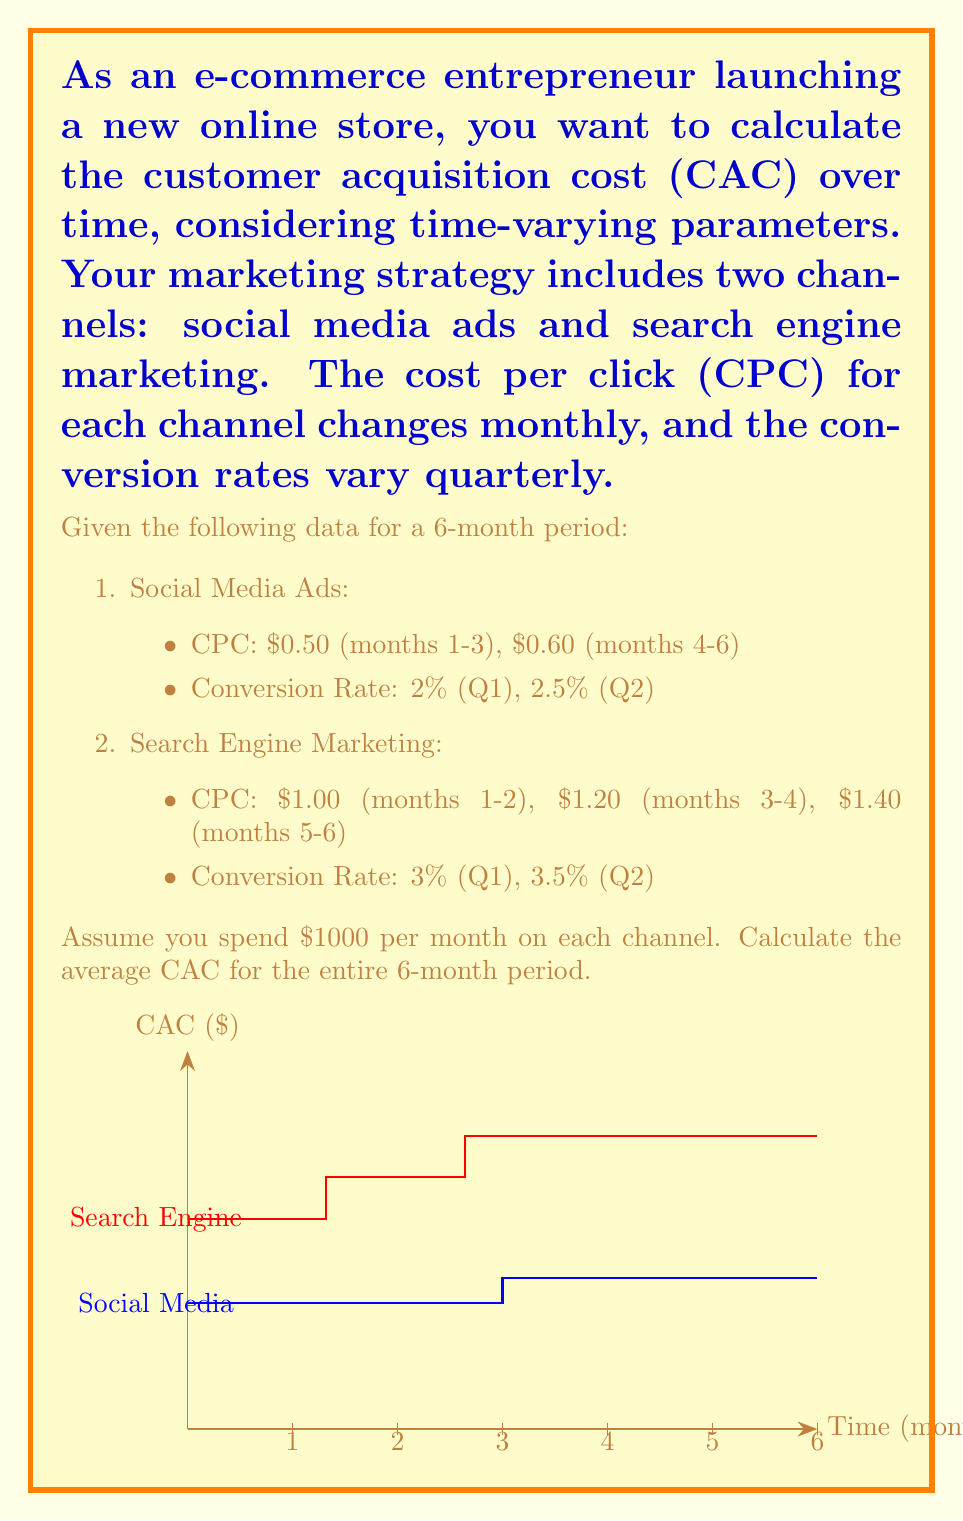Provide a solution to this math problem. To calculate the average Customer Acquisition Cost (CAC) over the 6-month period, we need to:

1. Calculate the number of customers acquired through each channel for each month.
2. Calculate the total cost for each channel.
3. Sum up the total customers and total costs.
4. Divide the total cost by the total number of customers.

Let's break it down step by step:

1. Number of customers acquired:

   Social Media Ads:
   - Months 1-3: $\frac{1000}{0.50} \times 0.02 = 40$ customers/month
   - Months 4-6: $\frac{1000}{0.60} \times 0.025 = 41.67$ customers/month
   
   Search Engine Marketing:
   - Months 1-2: $\frac{1000}{1.00} \times 0.03 = 30$ customers/month
   - Months 3-4: $\frac{1000}{1.20} \times 0.03 = 25$ customers/month
   - Months 5-6: $\frac{1000}{1.40} \times 0.035 = 25$ customers/month

2. Total customers acquired:
   $$(40 \times 3 + 41.67 \times 3) + (30 \times 2 + 25 \times 2 + 25 \times 2) = 245 + 160 = 405$$ customers

3. Total cost:
   $1000 \times 6 \times 2 = 12000$ (2 channels, $1000 per month, 6 months)

4. Average CAC:
   $$\text{Average CAC} = \frac{\text{Total Cost}}{\text{Total Customers}} = \frac{12000}{405} = 29.63$$
Answer: $29.63 